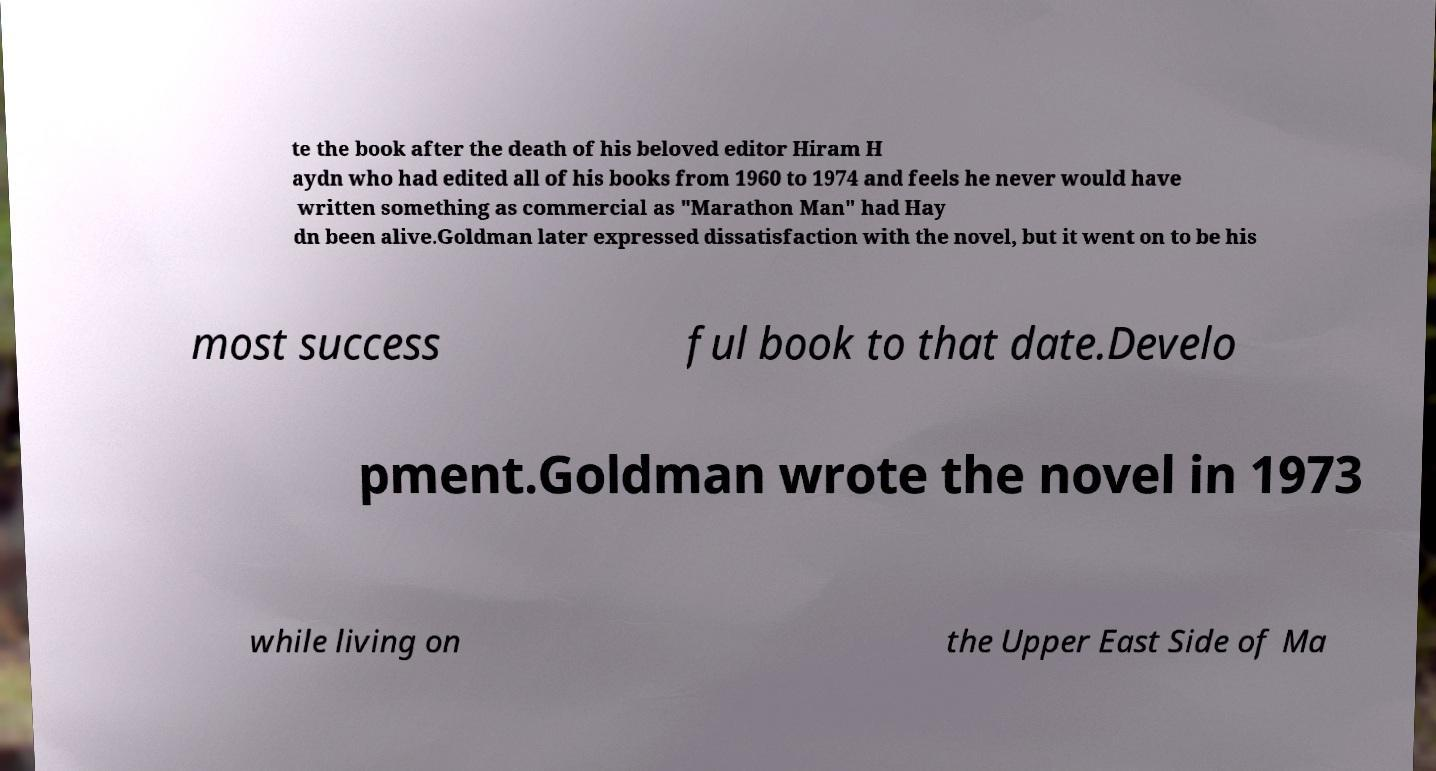Can you read and provide the text displayed in the image?This photo seems to have some interesting text. Can you extract and type it out for me? te the book after the death of his beloved editor Hiram H aydn who had edited all of his books from 1960 to 1974 and feels he never would have written something as commercial as "Marathon Man" had Hay dn been alive.Goldman later expressed dissatisfaction with the novel, but it went on to be his most success ful book to that date.Develo pment.Goldman wrote the novel in 1973 while living on the Upper East Side of Ma 